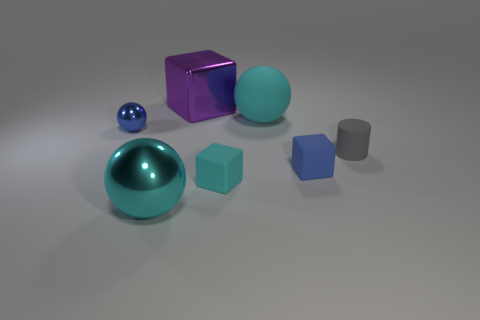Subtract all small matte blocks. How many blocks are left? 1 Subtract all cyan spheres. How many spheres are left? 1 Add 3 tiny brown rubber spheres. How many objects exist? 10 Subtract all cylinders. How many objects are left? 6 Subtract 1 cylinders. How many cylinders are left? 0 Subtract all gray cylinders. How many green spheres are left? 0 Subtract all cyan matte balls. Subtract all metal balls. How many objects are left? 4 Add 2 cyan matte things. How many cyan matte things are left? 4 Add 7 large cyan things. How many large cyan things exist? 9 Subtract 0 brown cubes. How many objects are left? 7 